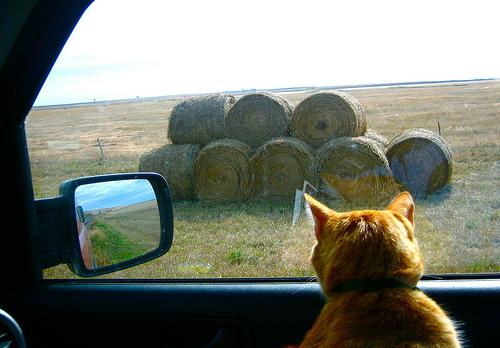Question: what is the cat doing?
Choices:
A. Looking out the window.
B. Watching birds.
C. Watching a mouse.
D. Sunbathing.
Answer with the letter. Answer: A Question: what color is the cat?
Choices:
A. Brown.
B. Orange.
C. White.
D. Black.
Answer with the letter. Answer: B Question: why is the cat looking out the window?
Choices:
A. To see into the field.
B. To watch birds.
C. To watch a mouse.
D. To enjoy the sunlight.
Answer with the letter. Answer: A Question: what is in the field?
Choices:
A. Haystacks.
B. Trees.
C. Straw.
D. Cows.
Answer with the letter. Answer: A Question: where are the haystacks?
Choices:
A. In the grass.
B. Next to the barn.
C. In the field.
D. Behind the shed.
Answer with the letter. Answer: C Question: who is next to the haystack?
Choices:
A. A man.
B. A woman.
C. No One.
D. Children.
Answer with the letter. Answer: C 